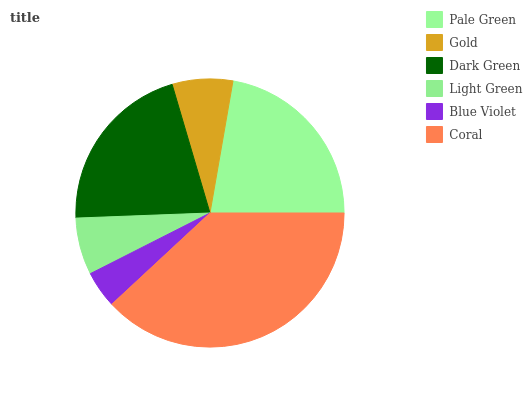Is Blue Violet the minimum?
Answer yes or no. Yes. Is Coral the maximum?
Answer yes or no. Yes. Is Gold the minimum?
Answer yes or no. No. Is Gold the maximum?
Answer yes or no. No. Is Pale Green greater than Gold?
Answer yes or no. Yes. Is Gold less than Pale Green?
Answer yes or no. Yes. Is Gold greater than Pale Green?
Answer yes or no. No. Is Pale Green less than Gold?
Answer yes or no. No. Is Dark Green the high median?
Answer yes or no. Yes. Is Gold the low median?
Answer yes or no. Yes. Is Blue Violet the high median?
Answer yes or no. No. Is Light Green the low median?
Answer yes or no. No. 